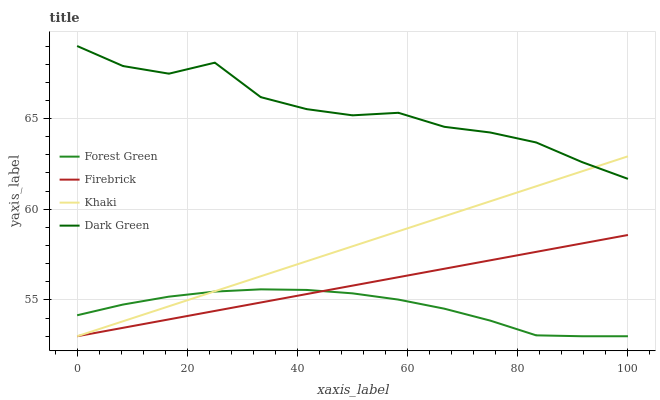Does Forest Green have the minimum area under the curve?
Answer yes or no. Yes. Does Dark Green have the maximum area under the curve?
Answer yes or no. Yes. Does Khaki have the minimum area under the curve?
Answer yes or no. No. Does Khaki have the maximum area under the curve?
Answer yes or no. No. Is Khaki the smoothest?
Answer yes or no. Yes. Is Dark Green the roughest?
Answer yes or no. Yes. Is Firebrick the smoothest?
Answer yes or no. No. Is Firebrick the roughest?
Answer yes or no. No. Does Dark Green have the lowest value?
Answer yes or no. No. Does Khaki have the highest value?
Answer yes or no. No. Is Forest Green less than Dark Green?
Answer yes or no. Yes. Is Dark Green greater than Forest Green?
Answer yes or no. Yes. Does Forest Green intersect Dark Green?
Answer yes or no. No. 